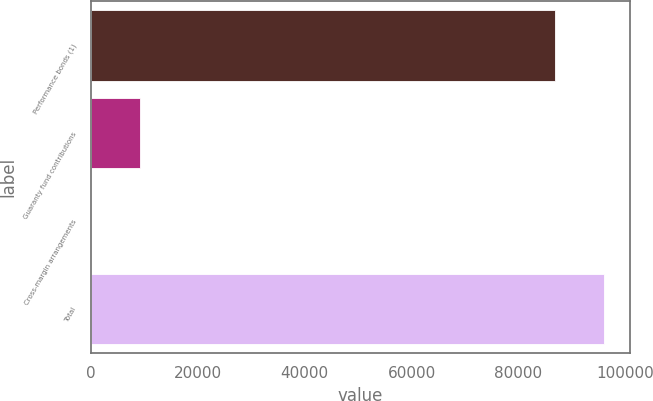Convert chart to OTSL. <chart><loc_0><loc_0><loc_500><loc_500><bar_chart><fcel>Performance bonds (1)<fcel>Guaranty fund contributions<fcel>Cross-margin arrangements<fcel>Total<nl><fcel>86730.4<fcel>9304.78<fcel>21.5<fcel>96013.7<nl></chart> 